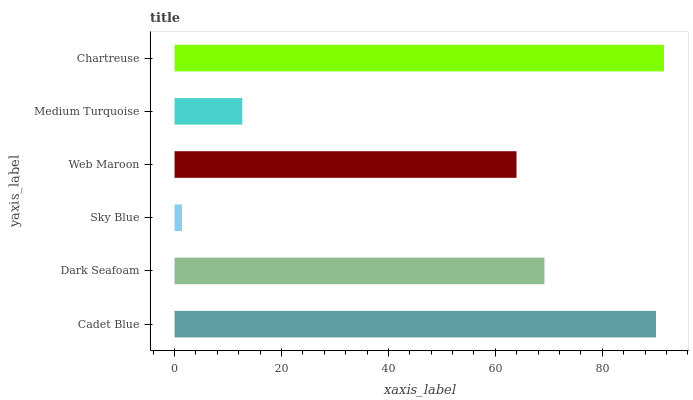Is Sky Blue the minimum?
Answer yes or no. Yes. Is Chartreuse the maximum?
Answer yes or no. Yes. Is Dark Seafoam the minimum?
Answer yes or no. No. Is Dark Seafoam the maximum?
Answer yes or no. No. Is Cadet Blue greater than Dark Seafoam?
Answer yes or no. Yes. Is Dark Seafoam less than Cadet Blue?
Answer yes or no. Yes. Is Dark Seafoam greater than Cadet Blue?
Answer yes or no. No. Is Cadet Blue less than Dark Seafoam?
Answer yes or no. No. Is Dark Seafoam the high median?
Answer yes or no. Yes. Is Web Maroon the low median?
Answer yes or no. Yes. Is Medium Turquoise the high median?
Answer yes or no. No. Is Sky Blue the low median?
Answer yes or no. No. 